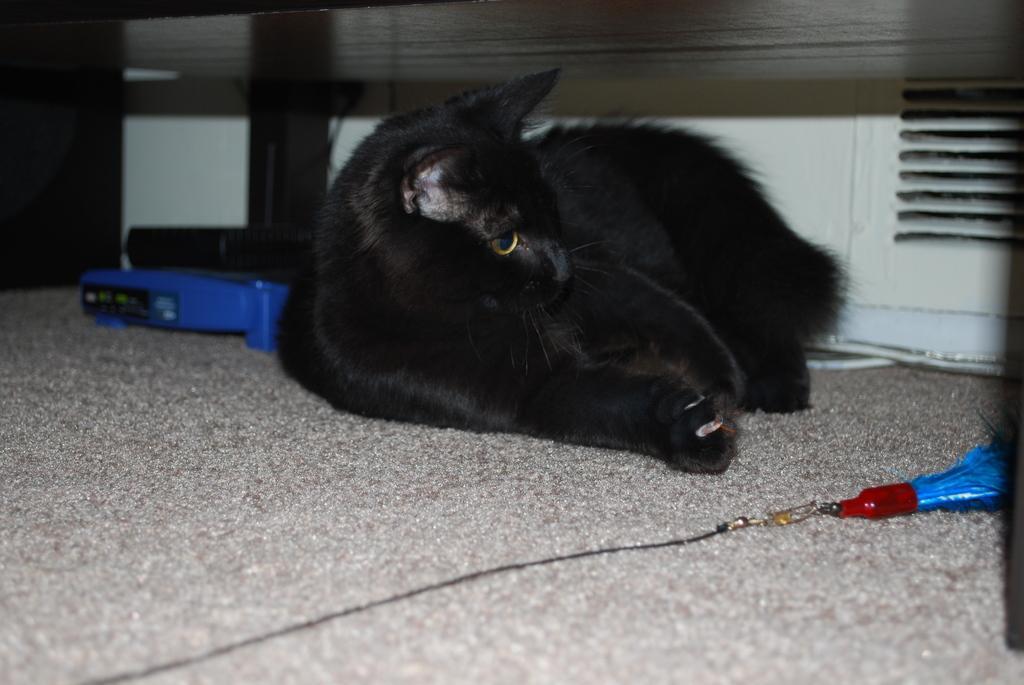Could you give a brief overview of what you see in this image? In this picture we can see a black color cat laying, at the bottom there is mat, we can see a key chain on the right side, on the left side it looks like a router. 